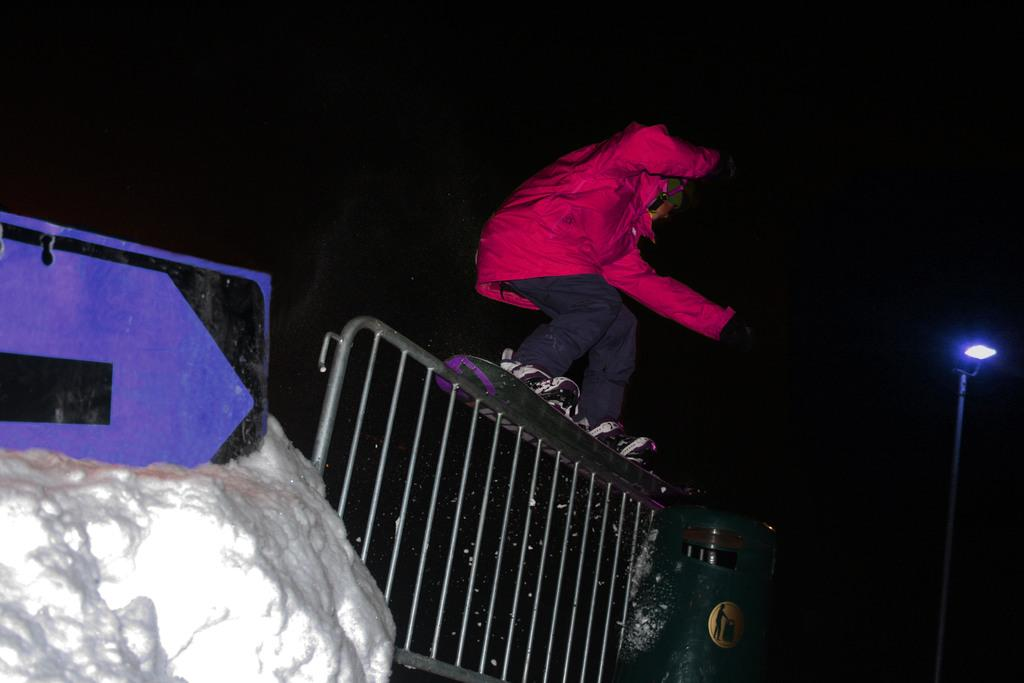What is the person in the image doing? There is a person skating in the image. On what surface is the person skating? The person is skating on a gate. What can be seen in the background of the image? There is a light, a bin, and a stone in the background of the image. What type of vegetable is being distributed by the engine in the image? There is no vegetable or engine present in the image. 